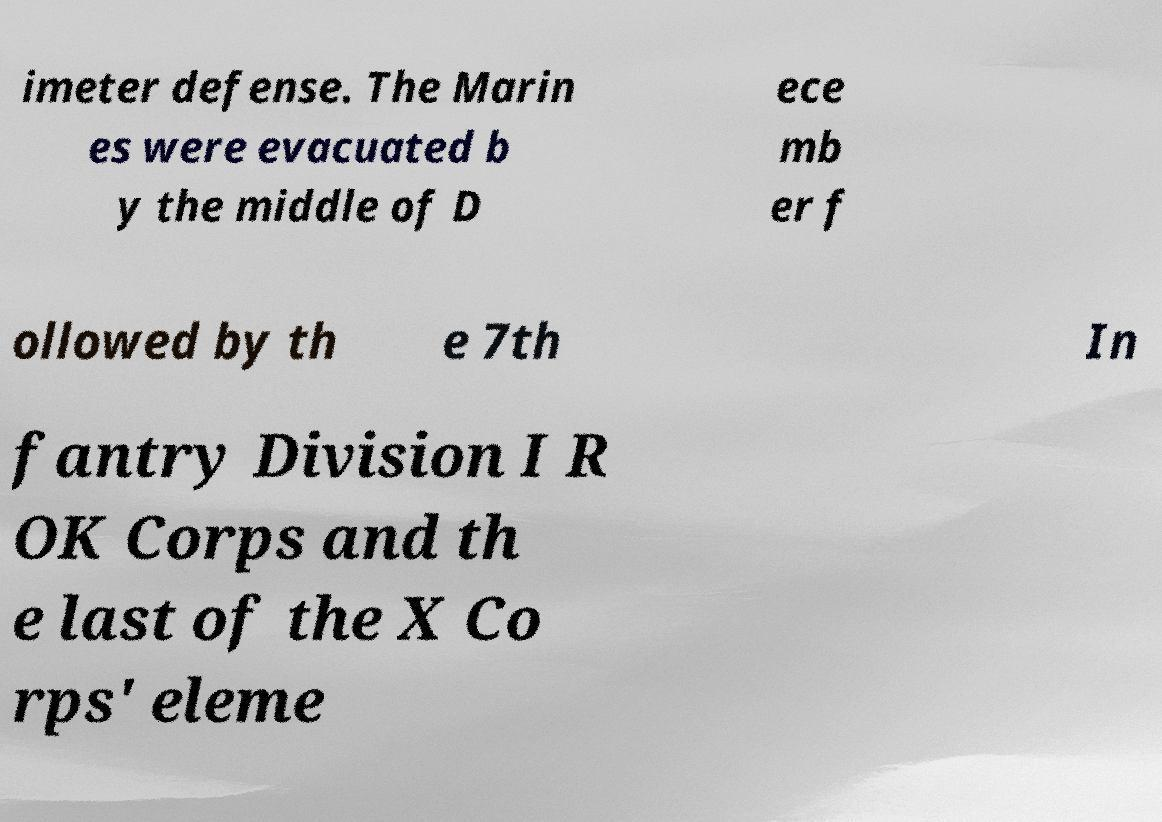Could you assist in decoding the text presented in this image and type it out clearly? imeter defense. The Marin es were evacuated b y the middle of D ece mb er f ollowed by th e 7th In fantry Division I R OK Corps and th e last of the X Co rps' eleme 